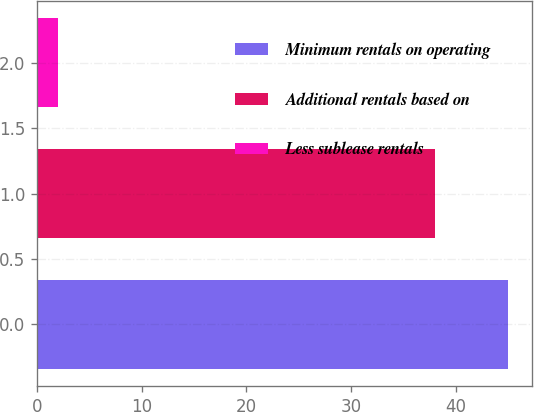<chart> <loc_0><loc_0><loc_500><loc_500><bar_chart><fcel>Minimum rentals on operating<fcel>Additional rentals based on<fcel>Less sublease rentals<nl><fcel>45<fcel>38<fcel>2<nl></chart> 